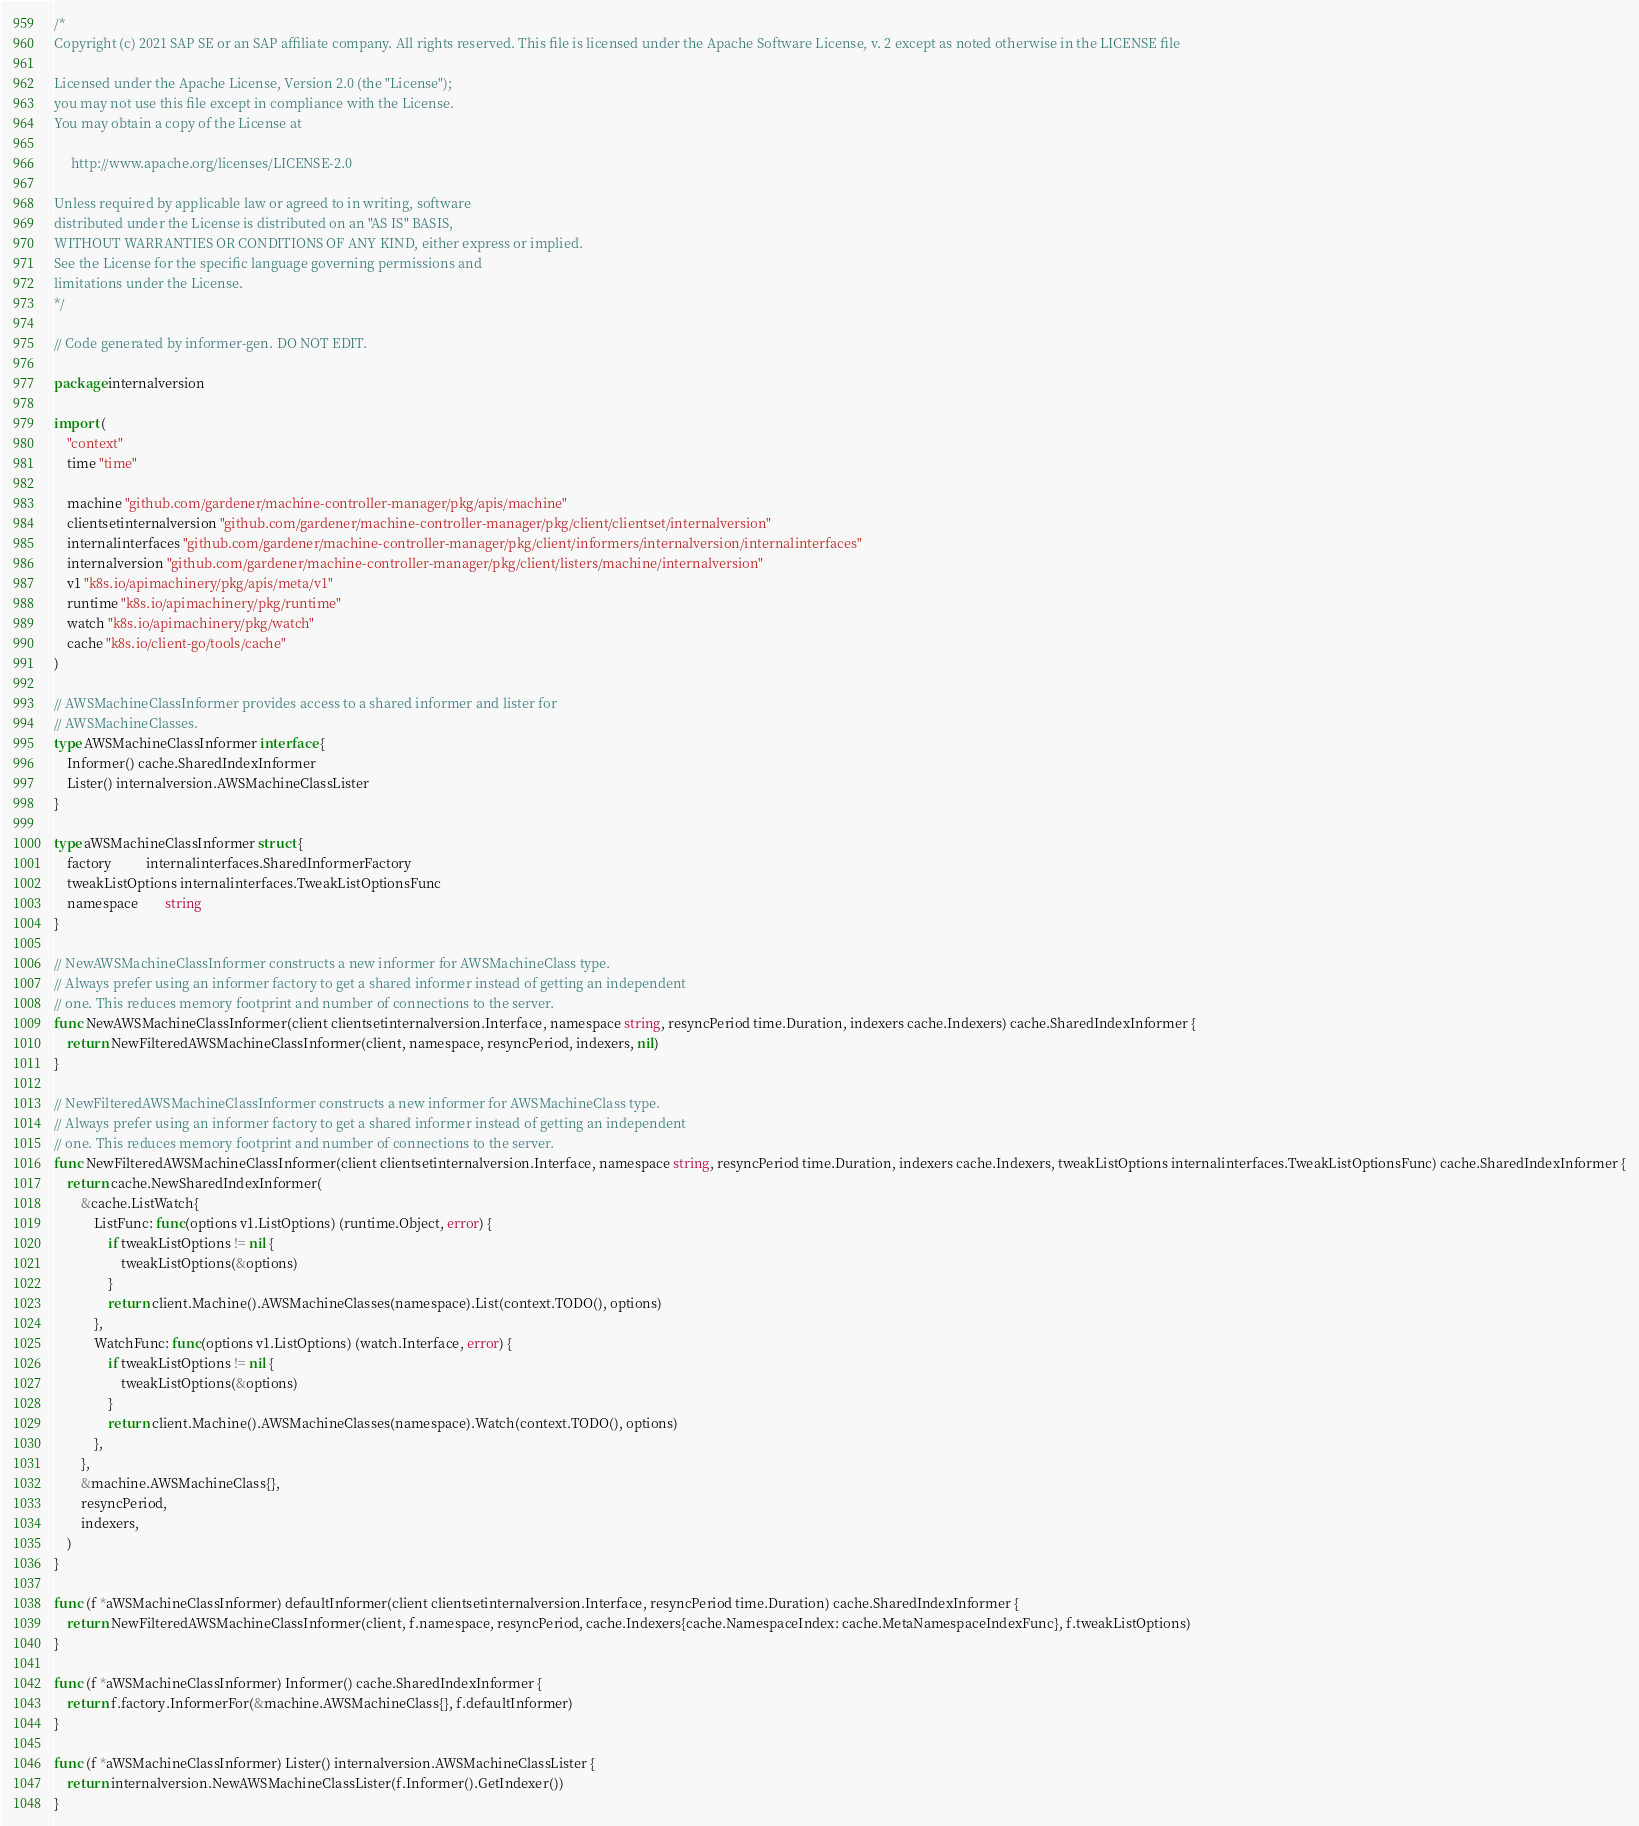<code> <loc_0><loc_0><loc_500><loc_500><_Go_>/*
Copyright (c) 2021 SAP SE or an SAP affiliate company. All rights reserved. This file is licensed under the Apache Software License, v. 2 except as noted otherwise in the LICENSE file

Licensed under the Apache License, Version 2.0 (the "License");
you may not use this file except in compliance with the License.
You may obtain a copy of the License at

     http://www.apache.org/licenses/LICENSE-2.0

Unless required by applicable law or agreed to in writing, software
distributed under the License is distributed on an "AS IS" BASIS,
WITHOUT WARRANTIES OR CONDITIONS OF ANY KIND, either express or implied.
See the License for the specific language governing permissions and
limitations under the License.
*/

// Code generated by informer-gen. DO NOT EDIT.

package internalversion

import (
	"context"
	time "time"

	machine "github.com/gardener/machine-controller-manager/pkg/apis/machine"
	clientsetinternalversion "github.com/gardener/machine-controller-manager/pkg/client/clientset/internalversion"
	internalinterfaces "github.com/gardener/machine-controller-manager/pkg/client/informers/internalversion/internalinterfaces"
	internalversion "github.com/gardener/machine-controller-manager/pkg/client/listers/machine/internalversion"
	v1 "k8s.io/apimachinery/pkg/apis/meta/v1"
	runtime "k8s.io/apimachinery/pkg/runtime"
	watch "k8s.io/apimachinery/pkg/watch"
	cache "k8s.io/client-go/tools/cache"
)

// AWSMachineClassInformer provides access to a shared informer and lister for
// AWSMachineClasses.
type AWSMachineClassInformer interface {
	Informer() cache.SharedIndexInformer
	Lister() internalversion.AWSMachineClassLister
}

type aWSMachineClassInformer struct {
	factory          internalinterfaces.SharedInformerFactory
	tweakListOptions internalinterfaces.TweakListOptionsFunc
	namespace        string
}

// NewAWSMachineClassInformer constructs a new informer for AWSMachineClass type.
// Always prefer using an informer factory to get a shared informer instead of getting an independent
// one. This reduces memory footprint and number of connections to the server.
func NewAWSMachineClassInformer(client clientsetinternalversion.Interface, namespace string, resyncPeriod time.Duration, indexers cache.Indexers) cache.SharedIndexInformer {
	return NewFilteredAWSMachineClassInformer(client, namespace, resyncPeriod, indexers, nil)
}

// NewFilteredAWSMachineClassInformer constructs a new informer for AWSMachineClass type.
// Always prefer using an informer factory to get a shared informer instead of getting an independent
// one. This reduces memory footprint and number of connections to the server.
func NewFilteredAWSMachineClassInformer(client clientsetinternalversion.Interface, namespace string, resyncPeriod time.Duration, indexers cache.Indexers, tweakListOptions internalinterfaces.TweakListOptionsFunc) cache.SharedIndexInformer {
	return cache.NewSharedIndexInformer(
		&cache.ListWatch{
			ListFunc: func(options v1.ListOptions) (runtime.Object, error) {
				if tweakListOptions != nil {
					tweakListOptions(&options)
				}
				return client.Machine().AWSMachineClasses(namespace).List(context.TODO(), options)
			},
			WatchFunc: func(options v1.ListOptions) (watch.Interface, error) {
				if tweakListOptions != nil {
					tweakListOptions(&options)
				}
				return client.Machine().AWSMachineClasses(namespace).Watch(context.TODO(), options)
			},
		},
		&machine.AWSMachineClass{},
		resyncPeriod,
		indexers,
	)
}

func (f *aWSMachineClassInformer) defaultInformer(client clientsetinternalversion.Interface, resyncPeriod time.Duration) cache.SharedIndexInformer {
	return NewFilteredAWSMachineClassInformer(client, f.namespace, resyncPeriod, cache.Indexers{cache.NamespaceIndex: cache.MetaNamespaceIndexFunc}, f.tweakListOptions)
}

func (f *aWSMachineClassInformer) Informer() cache.SharedIndexInformer {
	return f.factory.InformerFor(&machine.AWSMachineClass{}, f.defaultInformer)
}

func (f *aWSMachineClassInformer) Lister() internalversion.AWSMachineClassLister {
	return internalversion.NewAWSMachineClassLister(f.Informer().GetIndexer())
}
</code> 